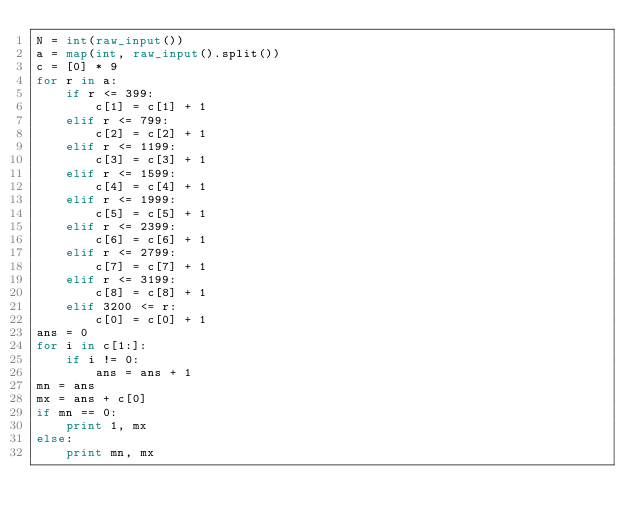Convert code to text. <code><loc_0><loc_0><loc_500><loc_500><_Python_>N = int(raw_input())
a = map(int, raw_input().split())
c = [0] * 9
for r in a:
    if r <= 399:
        c[1] = c[1] + 1
    elif r <= 799:
        c[2] = c[2] + 1
    elif r <= 1199:
        c[3] = c[3] + 1
    elif r <= 1599:
        c[4] = c[4] + 1
    elif r <= 1999:
        c[5] = c[5] + 1
    elif r <= 2399:
        c[6] = c[6] + 1
    elif r <= 2799:
        c[7] = c[7] + 1
    elif r <= 3199:
        c[8] = c[8] + 1
    elif 3200 <= r:
        c[0] = c[0] + 1
ans = 0
for i in c[1:]:
    if i != 0:
        ans = ans + 1
mn = ans
mx = ans + c[0]
if mn == 0:
    print 1, mx
else:
    print mn, mx</code> 